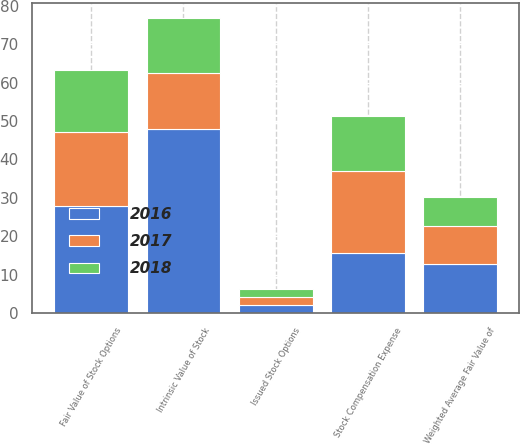<chart> <loc_0><loc_0><loc_500><loc_500><stacked_bar_chart><ecel><fcel>Intrinsic Value of Stock<fcel>Stock Compensation Expense<fcel>Issued Stock Options<fcel>Weighted Average Fair Value of<fcel>Fair Value of Stock Options<nl><fcel>2017<fcel>14.4<fcel>21.3<fcel>2<fcel>9.79<fcel>19.4<nl><fcel>2016<fcel>48<fcel>15.7<fcel>2.1<fcel>12.9<fcel>27.8<nl><fcel>2018<fcel>14.4<fcel>14.4<fcel>2.1<fcel>7.57<fcel>16.1<nl></chart> 